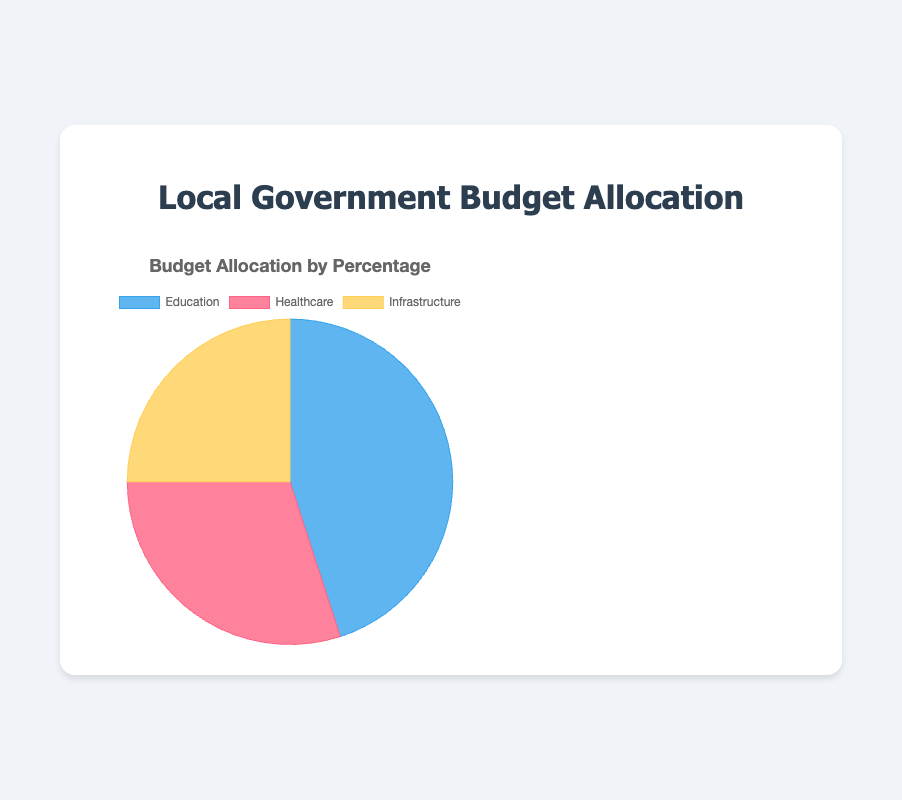What is the largest category of the budget allocation? The pie chart shows the budget allocation percentages for three categories: Education, Healthcare, and Infrastructure. Education has the highest percentage at 45%.
Answer: Education How much more is allocated to Education than Infrastructure? Education is allocated 45% of the budget, while Infrastructure is allocated 25%. The difference is 45 - 25 = 20%.
Answer: 20% Compare the allocation for Healthcare and Infrastructure. Which one is higher and by how much? Healthcare is allocated 30% of the budget, whereas Infrastructure is allocated 25%. Healthcare has 30 - 25 = 5% more than Infrastructure.
Answer: Healthcare by 5% How much of the budget is allocated to Healthcare and Infrastructure combined? Healthcare has 30% and Infrastructure has 25%. Combining them gives 30 + 25 = 55%.
Answer: 55% Which category is allocated the least budget and by what percentage? According to the pie chart, Infrastructure is allocated 25%, which is the smallest percentage compared to Education and Healthcare.
Answer: Infrastructure by 25% What is the combined percentage allocation for Education and Healthcare? Education has 45% and Healthcare has 30% of the budget. Adding these gives 45 + 30 = 75%.
Answer: 75% Which color represents the Education category in the pie chart? The visual inspection of the pie chart shows that Education is represented by the blue color.
Answer: Blue Explain the difference in allocation between the highest and lowest budget categories. Education has the highest allocation at 45%, while Infrastructure has the lowest at 25%. The difference is 45 - 25 = 20%.
Answer: 20% If the total budget is $10,000,000, how much money is allocated to Healthcare? Healthcare is allocated 30% of the budget. Therefore, 30% of $10,000,000 is calculated as 0.30 * 10,000,000 = $3,000,000.
Answer: $3,000,000 What percentage of the budget is left if you remove the allocation for Education? Education accounts for 45% of the budget. The remaining percentage after removing Education's allocation is 100 - 45 = 55%.
Answer: 55% 